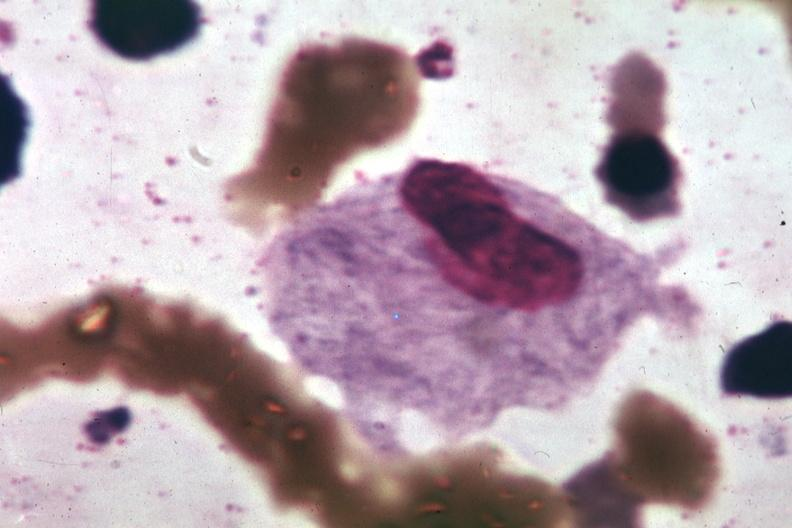s the unknown origin in mandible present?
Answer the question using a single word or phrase. No 